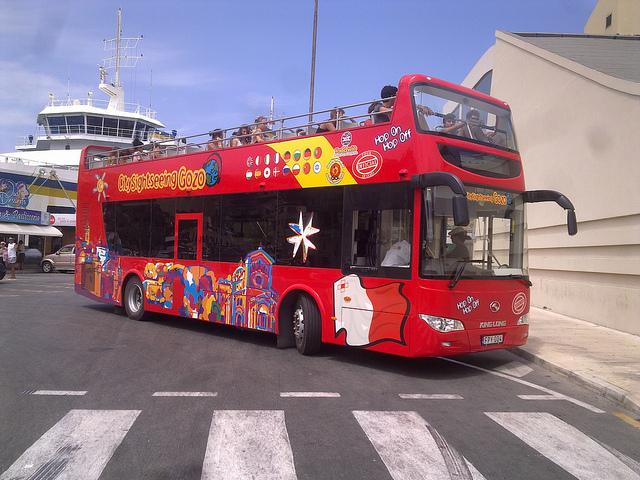What is the name for this type of vehicle? Please explain your reasoning. double decker. It is called a double decker because it has two levels. 